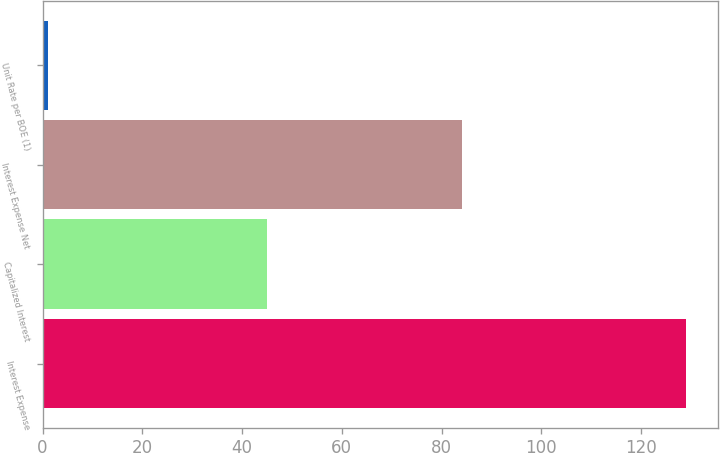<chart> <loc_0><loc_0><loc_500><loc_500><bar_chart><fcel>Interest Expense<fcel>Capitalized Interest<fcel>Interest Expense Net<fcel>Unit Rate per BOE (1)<nl><fcel>129<fcel>45<fcel>84<fcel>1.13<nl></chart> 